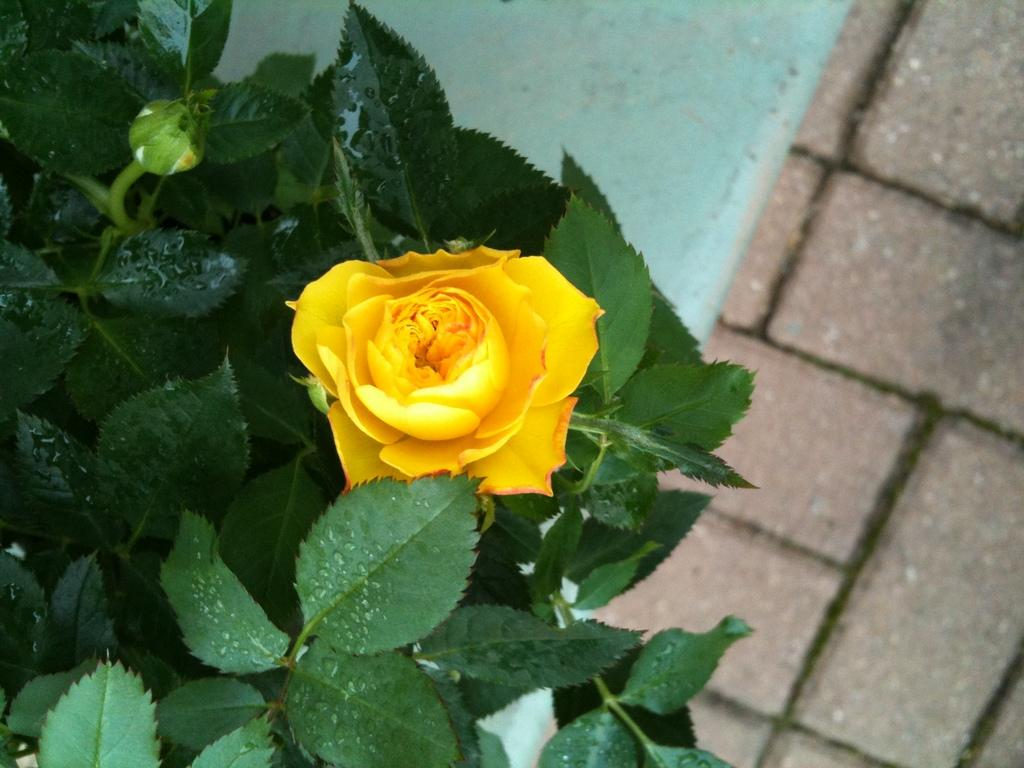What is present in the picture? There is a plant in the picture. Can you describe the plant's flower? The plant has a yellow flower. What is the plant's growth stage? The plant has a bud. What can be seen in the background of the picture? There is a pathway in the background of the picture. What type of apparel are the fairies wearing in the image? There are no fairies present in the image, so it is not possible to determine what type of apparel they might be wearing. 